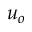Convert formula to latex. <formula><loc_0><loc_0><loc_500><loc_500>u _ { o }</formula> 